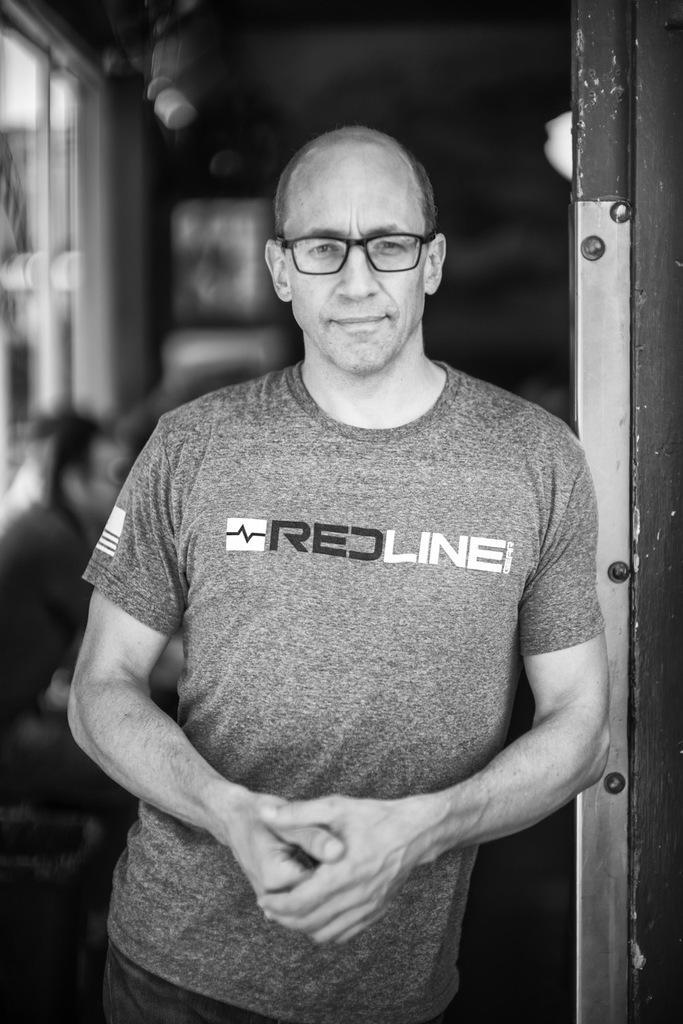Describe this image in one or two sentences. In this image we can see a person wearing t shirt and spectacles is standing. In the background ,we can see group of people and a window. 